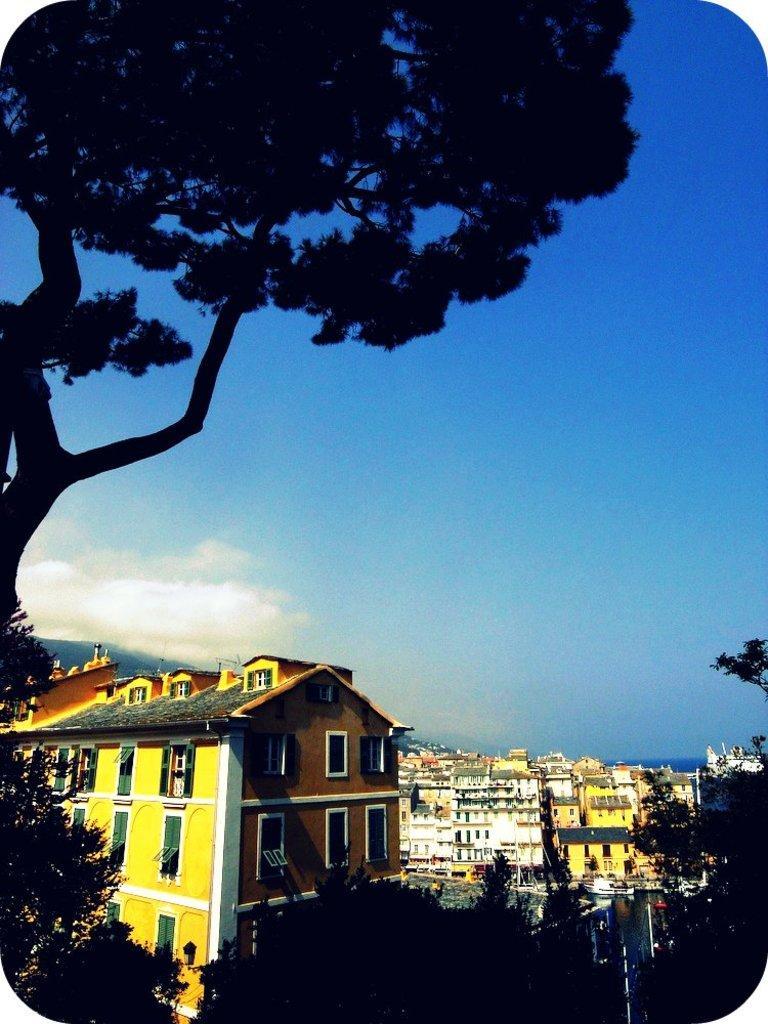Can you describe this image briefly? There are some trees and buildings at the bottom of this image and there is one tree as we can see at the top of this image. There is a blue sky in the background. 